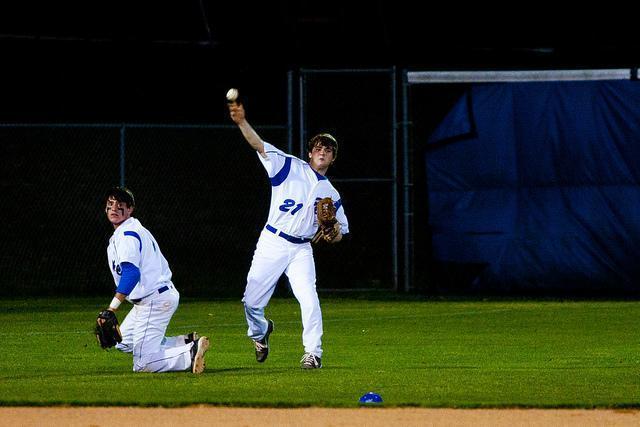How many people are there?
Give a very brief answer. 2. How many sandwiches have pickles?
Give a very brief answer. 0. 